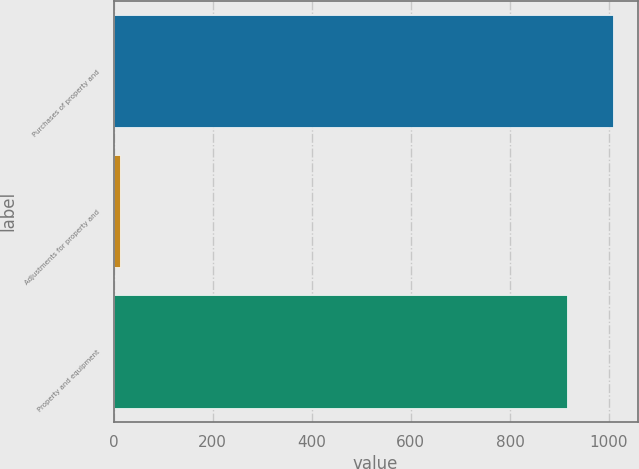<chart> <loc_0><loc_0><loc_500><loc_500><bar_chart><fcel>Purchases of property and<fcel>Adjustments for property and<fcel>Property and equipment<nl><fcel>1007.16<fcel>12.2<fcel>915.6<nl></chart> 